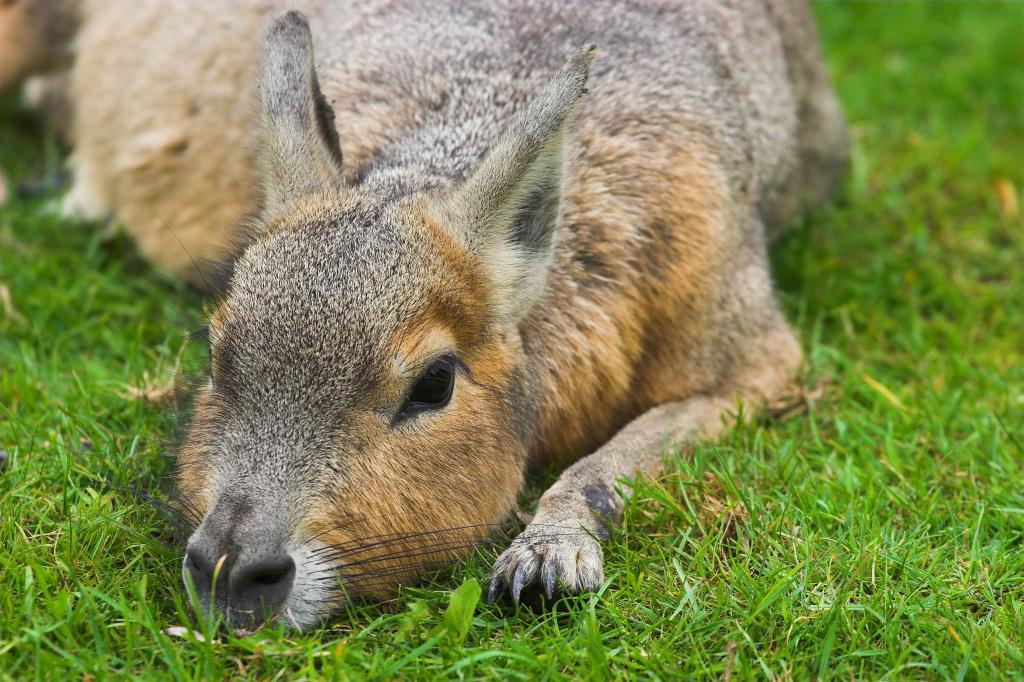What is the main subject of the picture? There is an animal in the picture. Where is the animal located in the image? The animal is lying on the grass surface. What colors can be seen on the animal? The animal has a light brown and gray color. What type of comb is the stranger using on the animal in the image? There is no stranger or comb present in the image; it only features an animal lying on the grass. 